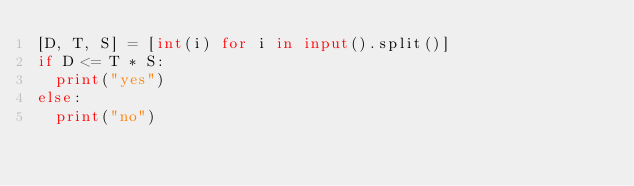Convert code to text. <code><loc_0><loc_0><loc_500><loc_500><_Python_>[D, T, S] = [int(i) for i in input().split()]
if D <= T * S:
  print("yes")
else:
  print("no")</code> 